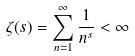<formula> <loc_0><loc_0><loc_500><loc_500>\zeta ( s ) = \sum _ { n = 1 } ^ { \infty } \frac { 1 } { n ^ { s } } < \infty</formula> 